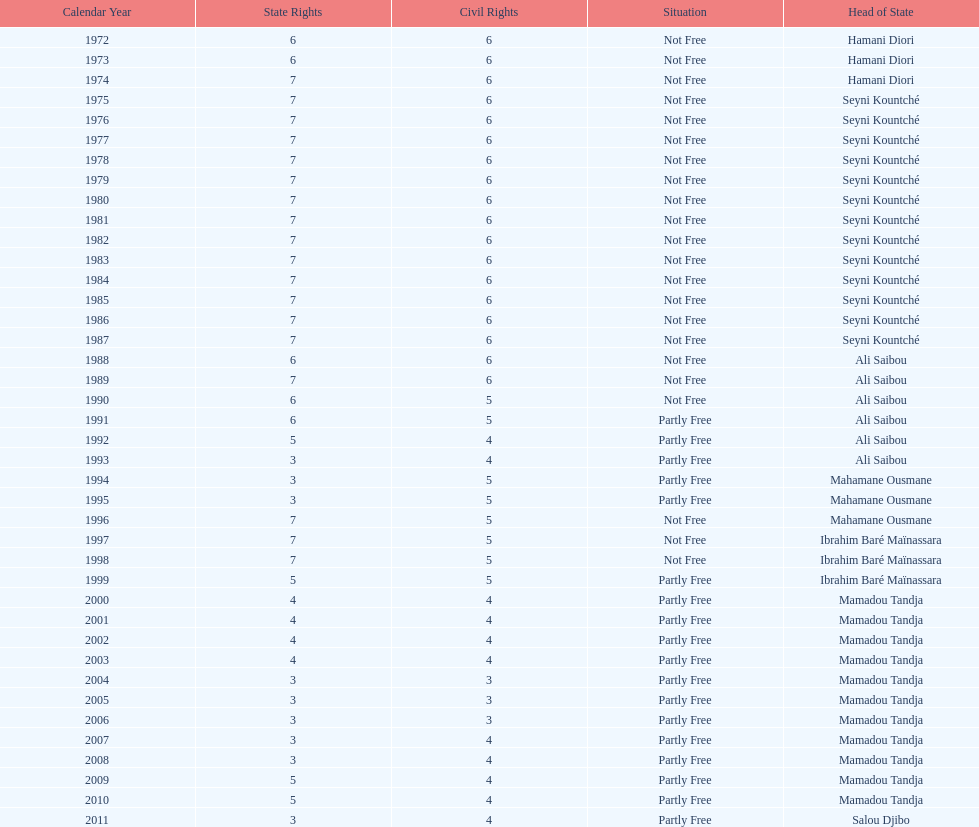Who was president before mamadou tandja? Ibrahim Baré Maïnassara. 